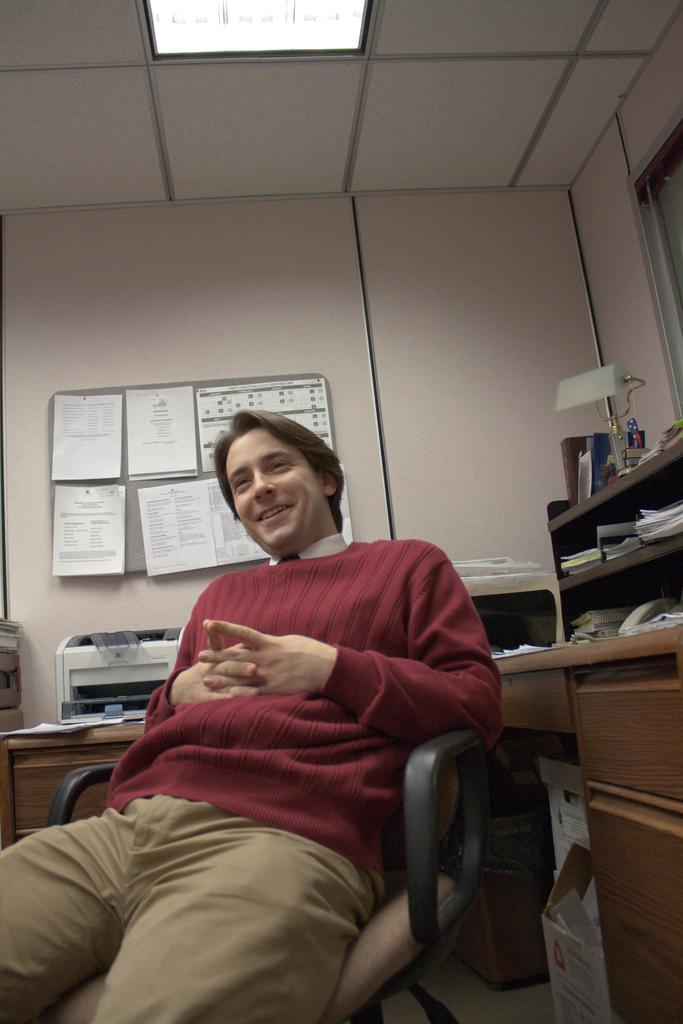What is the man in the image doing? The man is sitting on a chair in the image. What can be seen in the background of the image? There is a cupboard, books, a board, and a wall visible in the background of the image. Can you describe the cupboard in the image? The cupboard has books inside it. What type of unit is the man operating in the image? There is no indication of a unit or any work-related activity in the image; it simply shows a man sitting on a chair. 